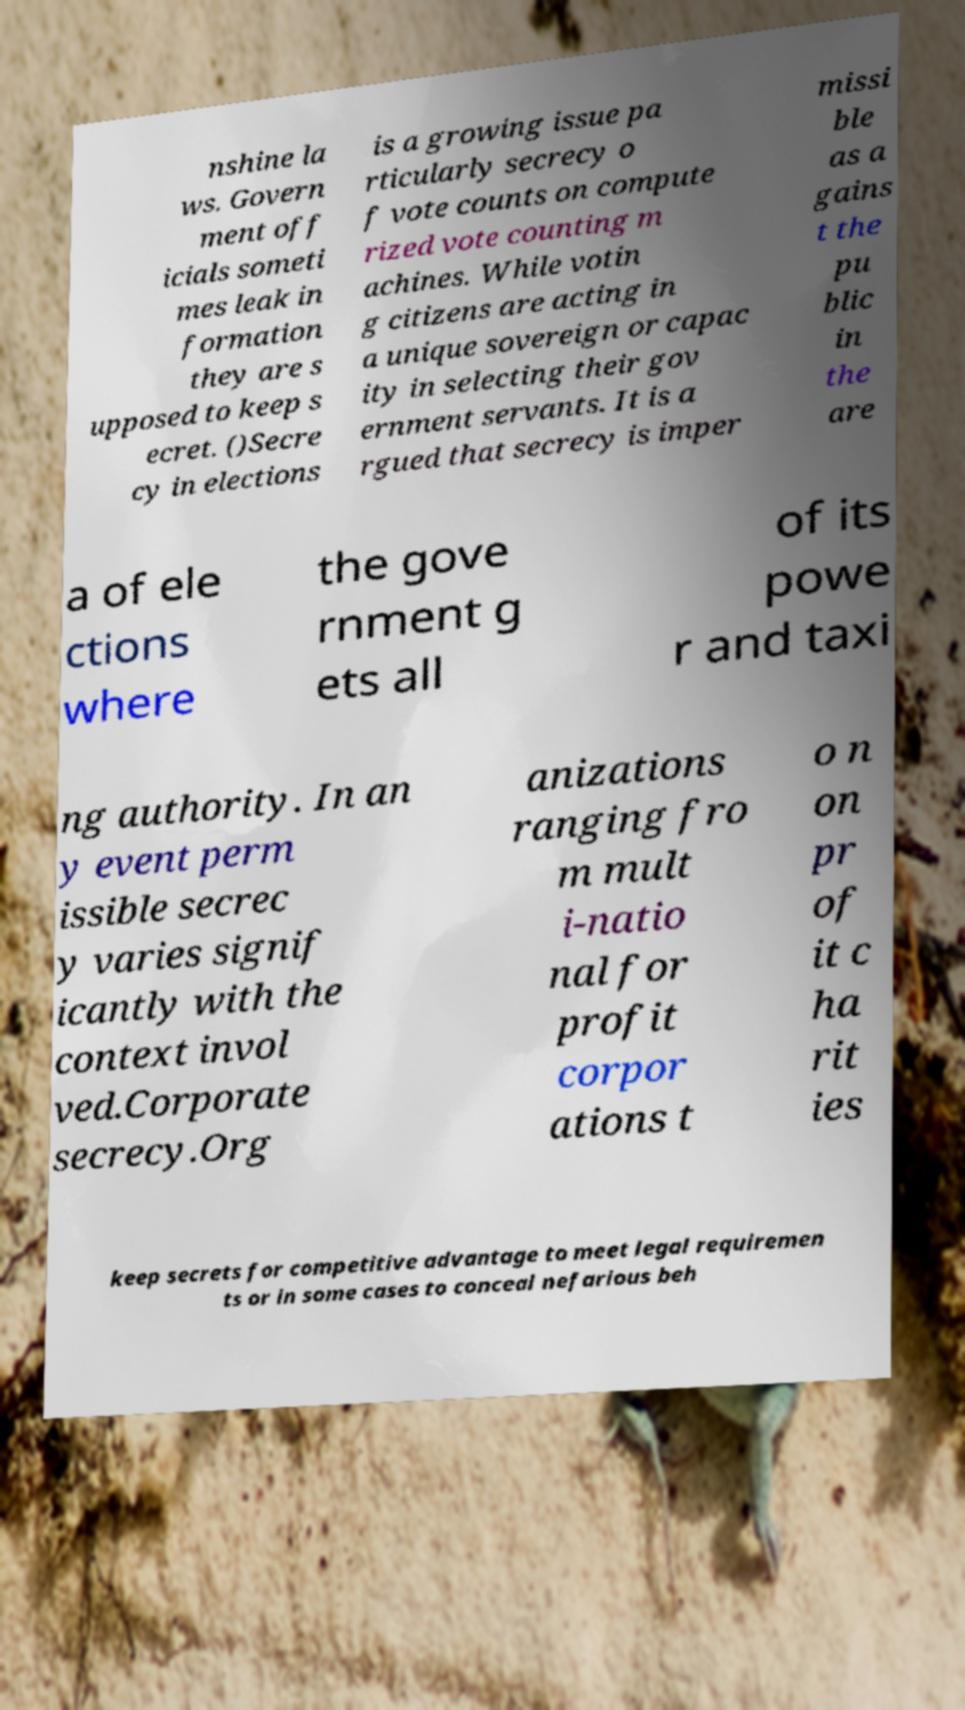Can you accurately transcribe the text from the provided image for me? nshine la ws. Govern ment off icials someti mes leak in formation they are s upposed to keep s ecret. ()Secre cy in elections is a growing issue pa rticularly secrecy o f vote counts on compute rized vote counting m achines. While votin g citizens are acting in a unique sovereign or capac ity in selecting their gov ernment servants. It is a rgued that secrecy is imper missi ble as a gains t the pu blic in the are a of ele ctions where the gove rnment g ets all of its powe r and taxi ng authority. In an y event perm issible secrec y varies signif icantly with the context invol ved.Corporate secrecy.Org anizations ranging fro m mult i-natio nal for profit corpor ations t o n on pr of it c ha rit ies keep secrets for competitive advantage to meet legal requiremen ts or in some cases to conceal nefarious beh 